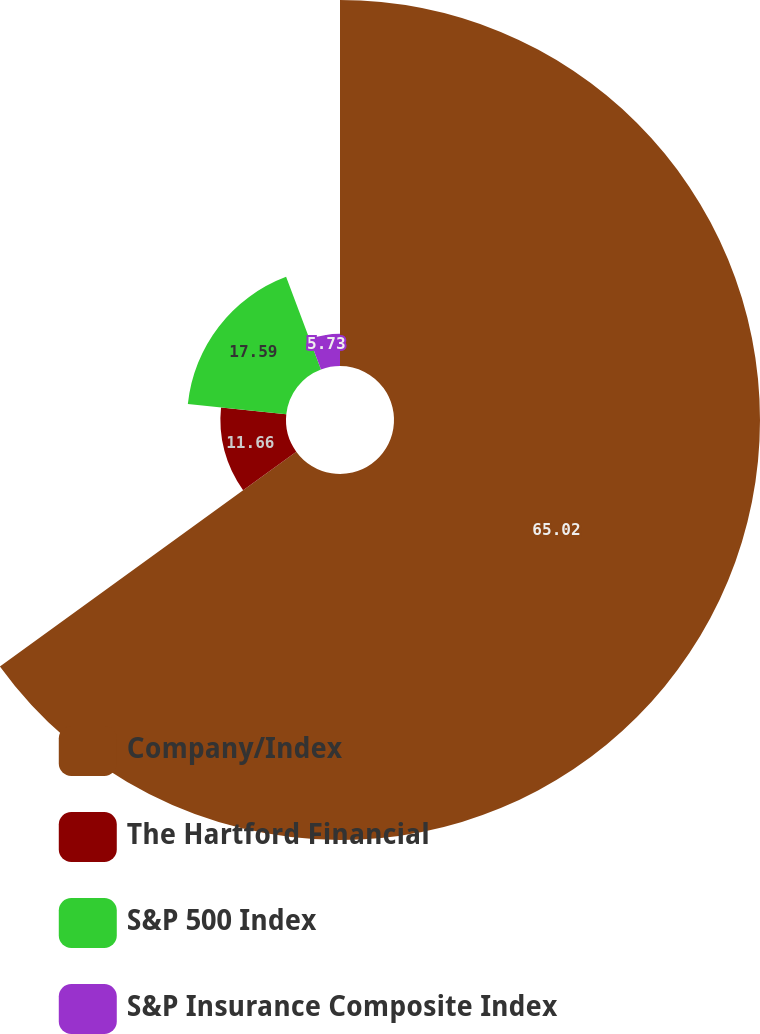Convert chart to OTSL. <chart><loc_0><loc_0><loc_500><loc_500><pie_chart><fcel>Company/Index<fcel>The Hartford Financial<fcel>S&P 500 Index<fcel>S&P Insurance Composite Index<nl><fcel>65.02%<fcel>11.66%<fcel>17.59%<fcel>5.73%<nl></chart> 